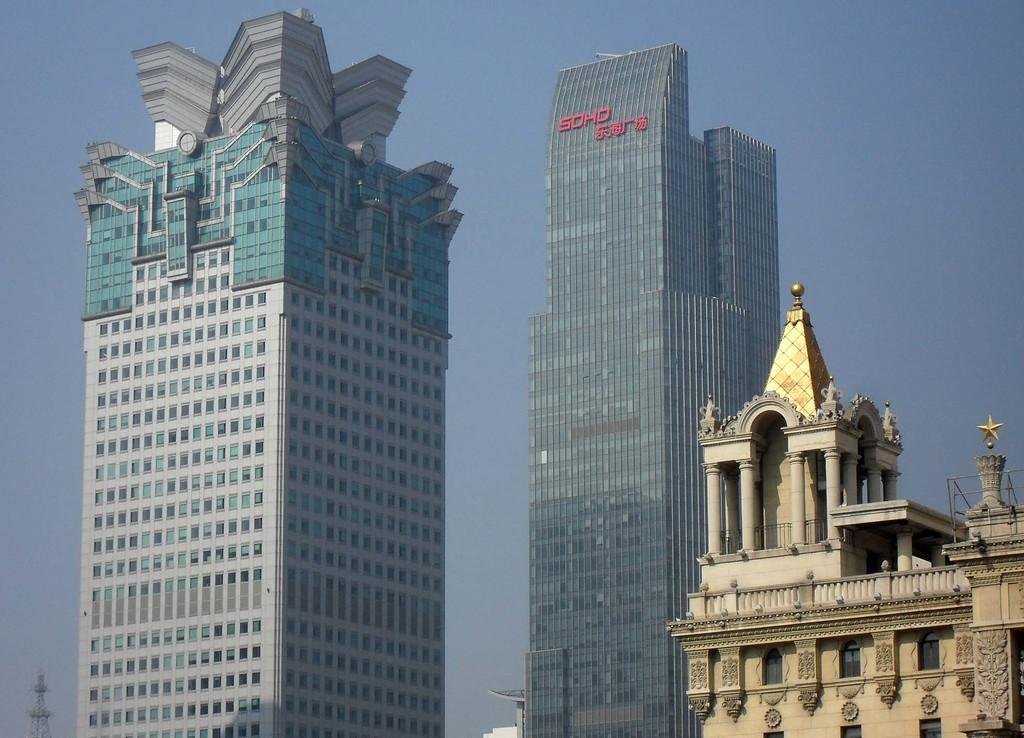What type of structures can be seen in the image? There are buildings in the image. Can you describe the tower in the image? The tower is located in the left bottom of the image. What can be seen in the background of the image? The sky is visible behind the buildings. What color is the partner's mouth in the image? There is no partner or mouth present in the image. 